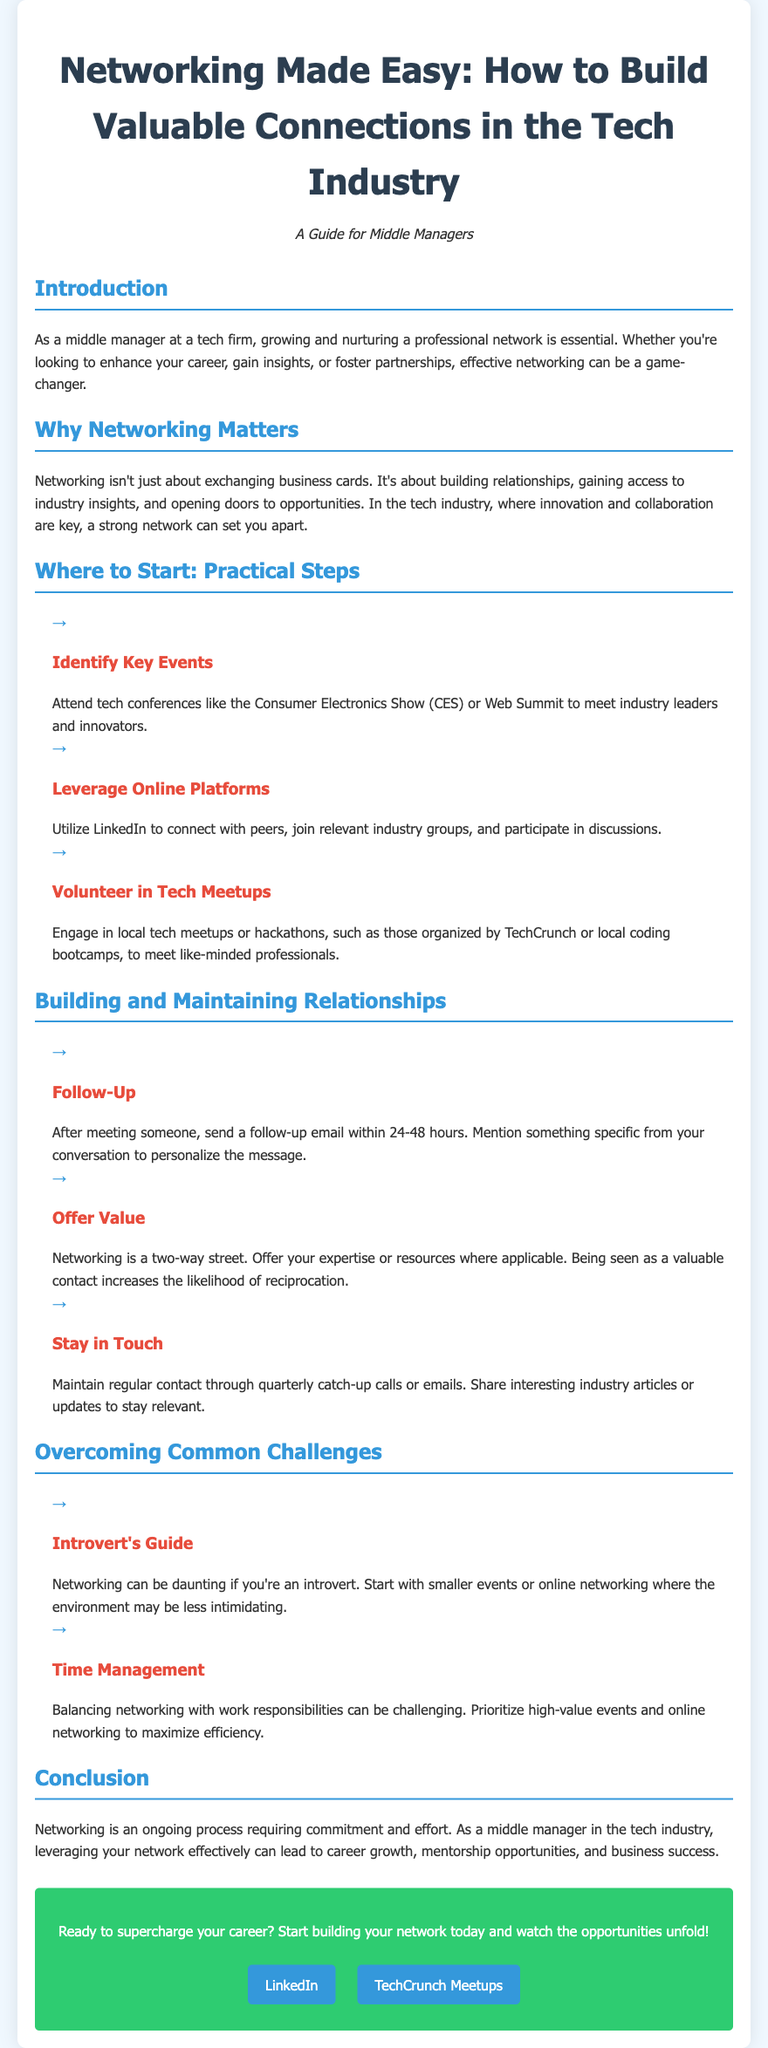What is the title of the flyer? The title is prominently displayed at the top of the document to capture the main theme.
Answer: Networking Made Easy: How to Build Valuable Connections in the Tech Industry What strategy is suggested for introverts? The document advises introverts to start with settings that are not too overwhelming for networking.
Answer: Start with smaller events or online networking Which online platform is recommended for networking? The flyer mentions a specific platform that is popular for professional networking.
Answer: LinkedIn What type of events should you attend to meet industry leaders? The flyer lists specific events that provide opportunities to connect with leaders in the tech industry.
Answer: Tech conferences What is suggested to maintain regular contact with connections? The document offers a recommendation on frequency for keeping in touch with professional contacts.
Answer: Quarterly catch-up calls or emails What color is used for headings in the document? The document's design includes a specific color for headings, emphasizing their importance.
Answer: Blue What should you mention in a follow-up email? The document provides a key detail to personalize follow-up communications after networking events.
Answer: Something specific from your conversation What is the overarching theme of the document? The main focus of the document is described through its title and content emphasis on connections.
Answer: Networking 